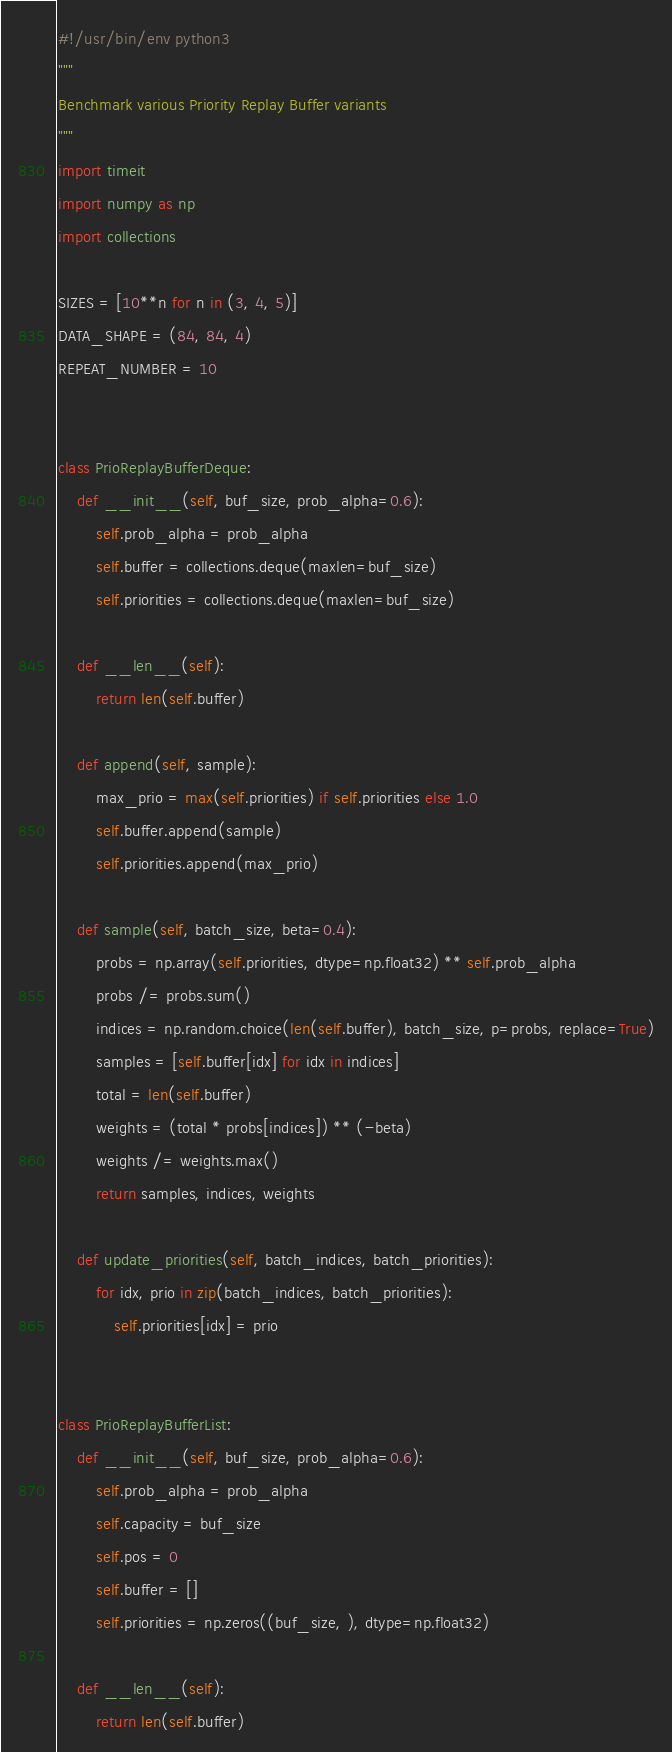<code> <loc_0><loc_0><loc_500><loc_500><_Python_>#!/usr/bin/env python3
"""
Benchmark various Priority Replay Buffer variants
"""
import timeit
import numpy as np
import collections

SIZES = [10**n for n in (3, 4, 5)]
DATA_SHAPE = (84, 84, 4)
REPEAT_NUMBER = 10


class PrioReplayBufferDeque:
    def __init__(self, buf_size, prob_alpha=0.6):
        self.prob_alpha = prob_alpha
        self.buffer = collections.deque(maxlen=buf_size)
        self.priorities = collections.deque(maxlen=buf_size)

    def __len__(self):
        return len(self.buffer)

    def append(self, sample):
        max_prio = max(self.priorities) if self.priorities else 1.0
        self.buffer.append(sample)
        self.priorities.append(max_prio)

    def sample(self, batch_size, beta=0.4):
        probs = np.array(self.priorities, dtype=np.float32) ** self.prob_alpha
        probs /= probs.sum()
        indices = np.random.choice(len(self.buffer), batch_size, p=probs, replace=True)
        samples = [self.buffer[idx] for idx in indices]
        total = len(self.buffer)
        weights = (total * probs[indices]) ** (-beta)
        weights /= weights.max()
        return samples, indices, weights

    def update_priorities(self, batch_indices, batch_priorities):
        for idx, prio in zip(batch_indices, batch_priorities):
            self.priorities[idx] = prio


class PrioReplayBufferList:
    def __init__(self, buf_size, prob_alpha=0.6):
        self.prob_alpha = prob_alpha
        self.capacity = buf_size
        self.pos = 0
        self.buffer = []
        self.priorities = np.zeros((buf_size, ), dtype=np.float32)

    def __len__(self):
        return len(self.buffer)
</code> 